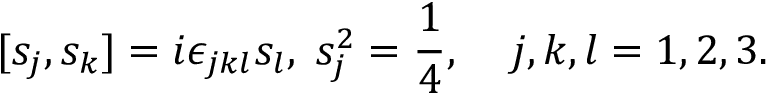Convert formula to latex. <formula><loc_0><loc_0><loc_500><loc_500>[ s _ { j } , s _ { k } ] = i \epsilon _ { j k l } s _ { l } , \, s _ { j } ^ { 2 } = \frac { 1 } { 4 } , \, j , k , l = 1 , 2 , 3 .</formula> 